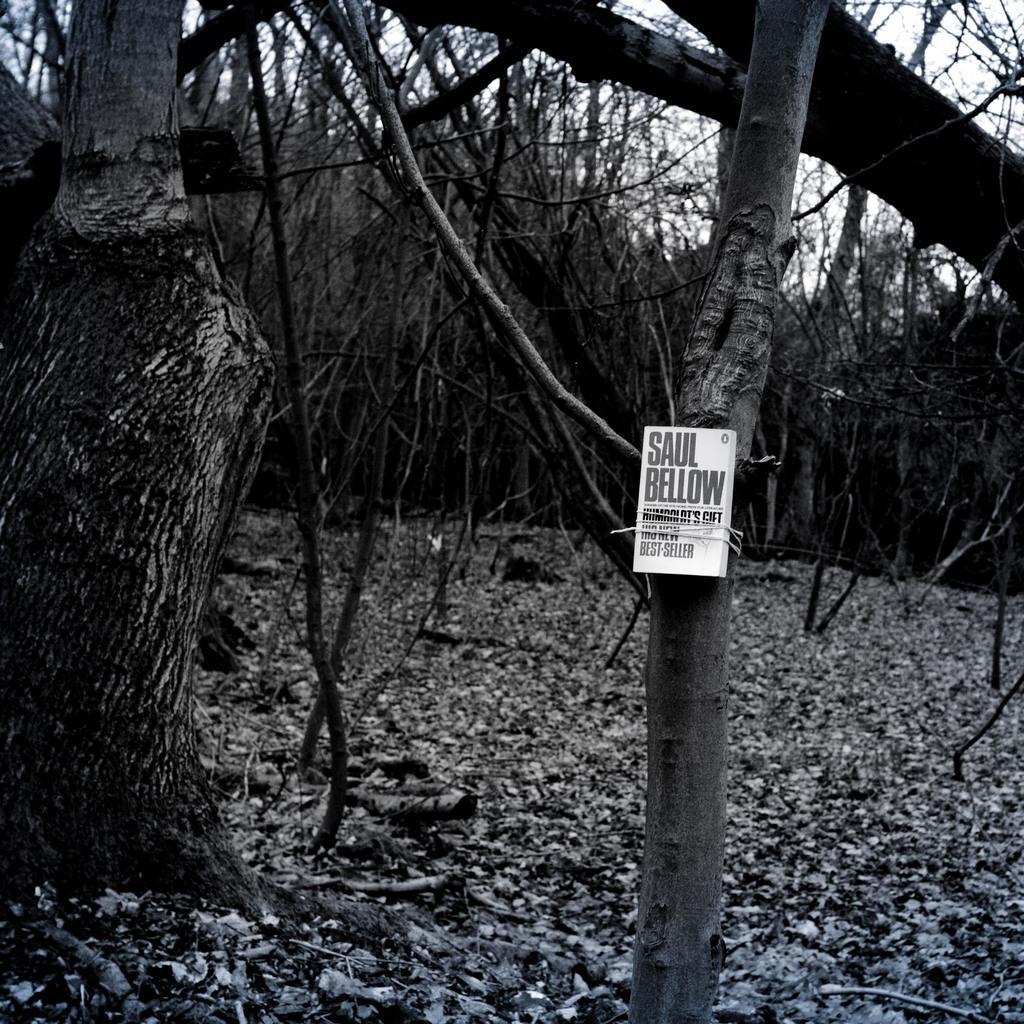Could you give a brief overview of what you see in this image? This is the picture of a black and white image and we can see some trees and dry leaves on the ground and there is a poster which looks like a book attached to the tree and there is some text on the book and we can see the sky. 